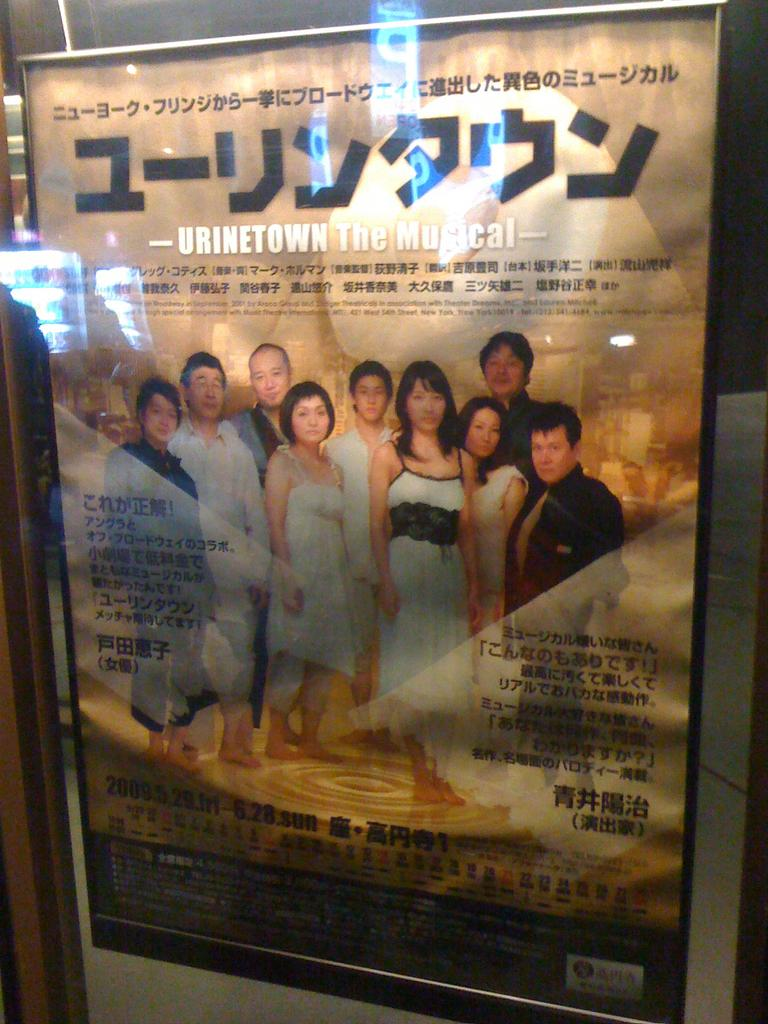What is attached to the wall in the image? There is a frame attached to the wall in the image. What is written or depicted on the frame? There is text on the frame. Are there any people in the image? Yes, there are people standing near the frame. What type of sheet is being used as apparel by the people in the image? There is no sheet or apparel mentioned in the image; it only features a frame with text and people standing nearby. 